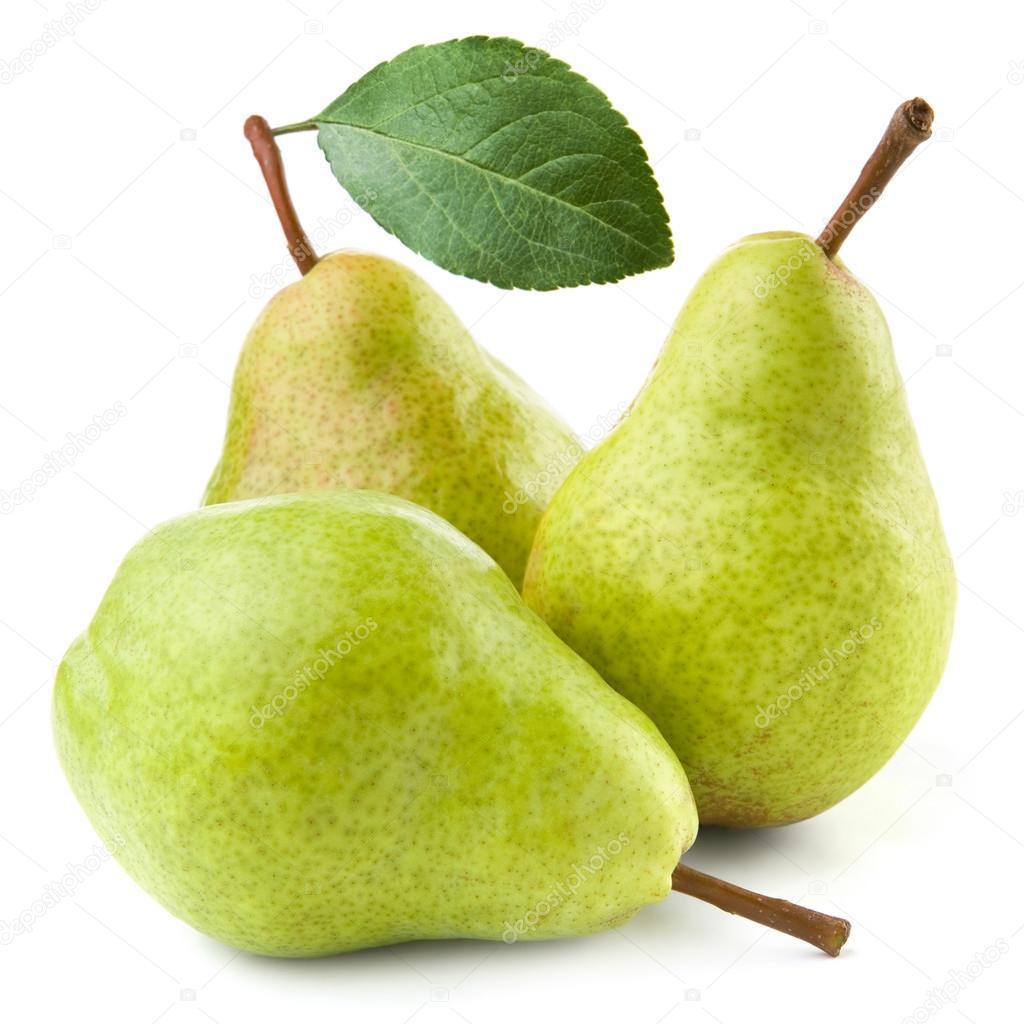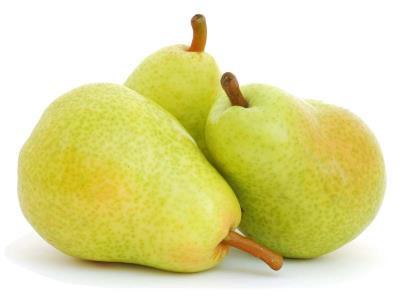The first image is the image on the left, the second image is the image on the right. For the images shown, is this caption "At least one of the images shows fruit hanging on a tree." true? Answer yes or no. No. The first image is the image on the left, the second image is the image on the right. Given the left and right images, does the statement "The left image includes at least one whole pear and a green leaf, and the right image contains at least three whole pears but no leaves." hold true? Answer yes or no. Yes. 